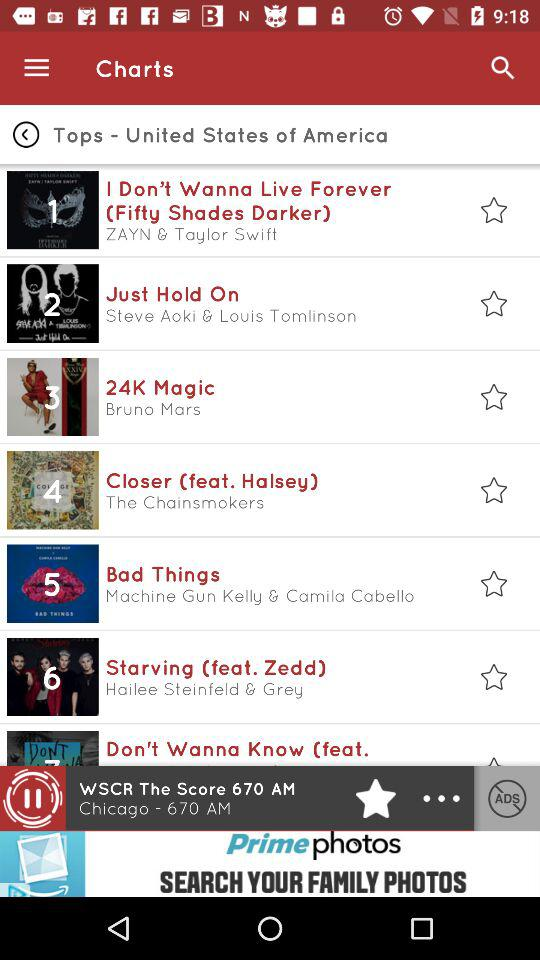What is the name of the singer of "24K Magic"? The name of the singer of "24K Magic" is Bruno Mars. 